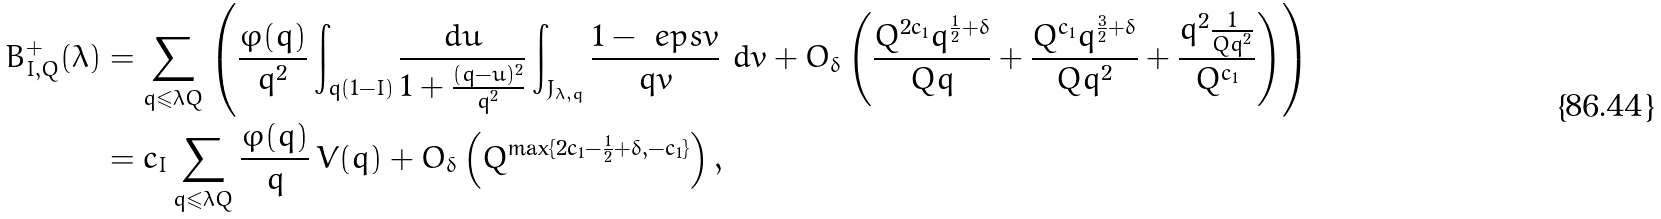<formula> <loc_0><loc_0><loc_500><loc_500>B _ { I , Q } ^ { + } ( \lambda ) & = \sum _ { q \leqslant \lambda Q } \left ( \frac { \varphi ( q ) } { q ^ { 2 } } \int _ { q ( 1 - I ) } \frac { d u } { 1 + \frac { ( q - u ) ^ { 2 } } { q ^ { 2 } } } \int _ { J _ { \lambda , q } } \frac { 1 - \ e p s v } { q v } \ d v + O _ { \delta } \left ( \frac { Q ^ { 2 c _ { 1 } } q ^ { \frac { 1 } { 2 } + \delta } } { Q q } + \frac { Q ^ { c _ { 1 } } q ^ { \frac { 3 } { 2 } + \delta } } { Q q ^ { 2 } } + \frac { q ^ { 2 } \frac { 1 } { Q q ^ { 2 } } } { Q ^ { c _ { 1 } } } \right ) \right ) \\ & = c _ { I } \sum _ { q \leqslant \lambda Q } \frac { \varphi ( q ) } { q } \, V ( q ) + O _ { \delta } \left ( Q ^ { \max \{ 2 c _ { 1 } - \frac { 1 } { 2 } + \delta , - c _ { 1 } \} } \right ) ,</formula> 